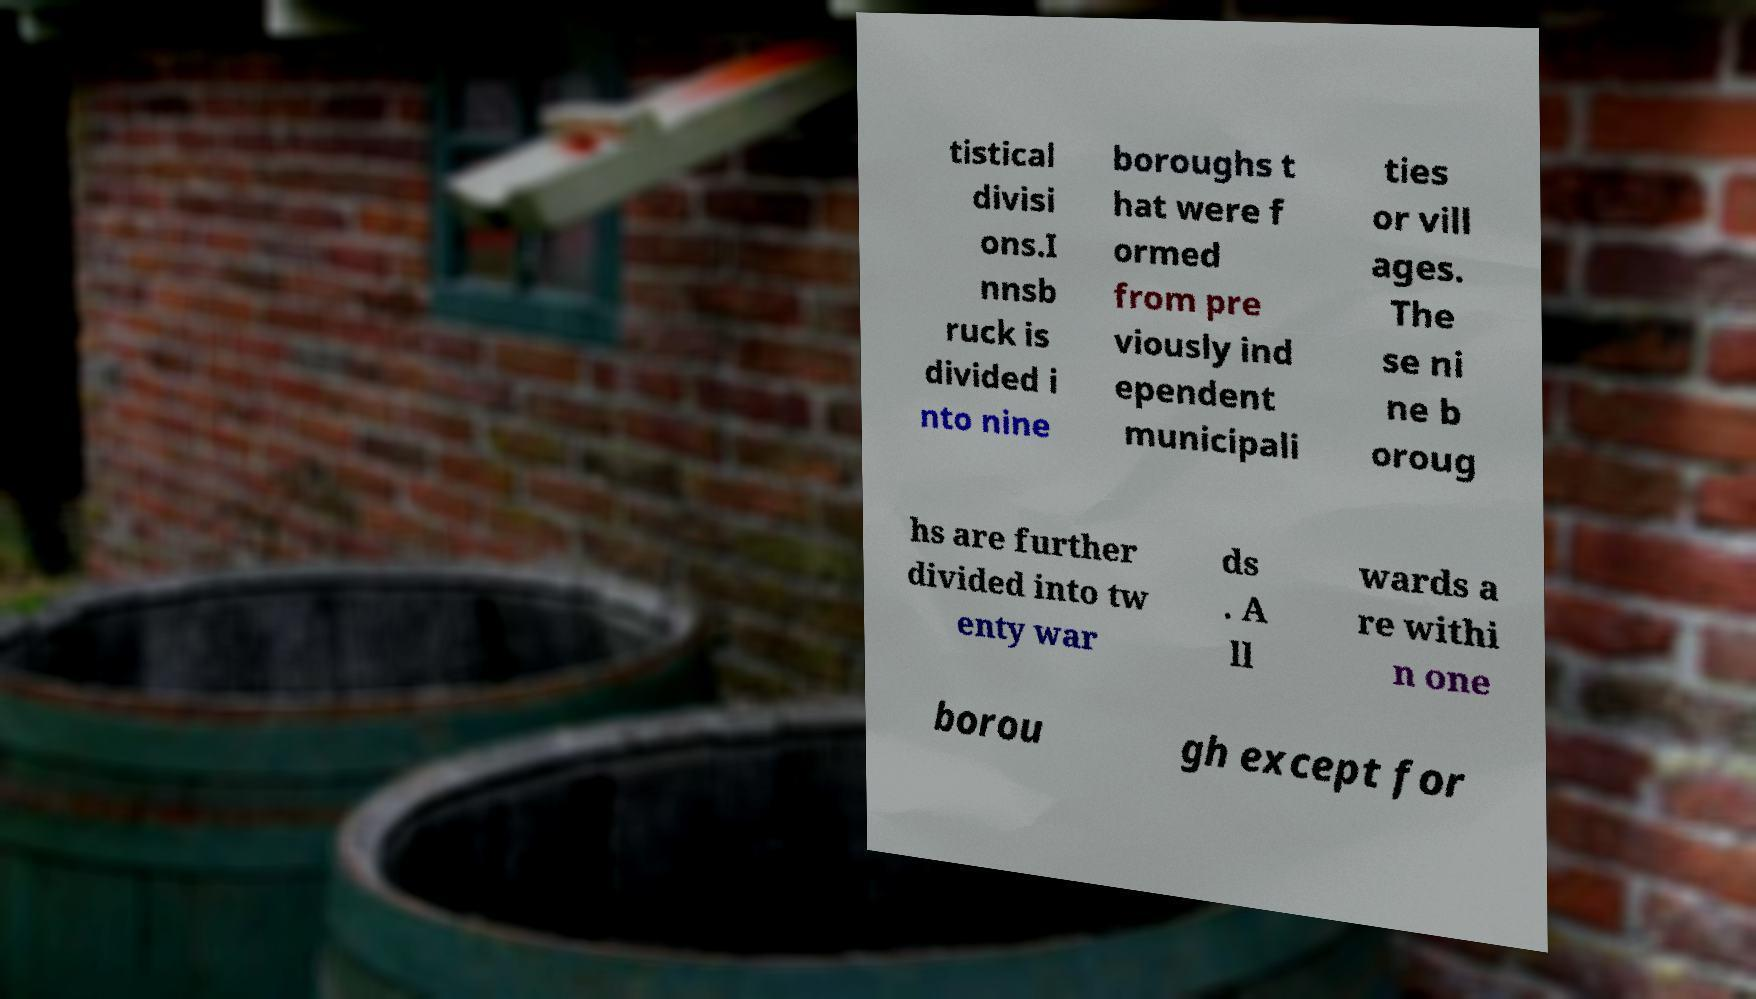Can you read and provide the text displayed in the image?This photo seems to have some interesting text. Can you extract and type it out for me? tistical divisi ons.I nnsb ruck is divided i nto nine boroughs t hat were f ormed from pre viously ind ependent municipali ties or vill ages. The se ni ne b oroug hs are further divided into tw enty war ds . A ll wards a re withi n one borou gh except for 